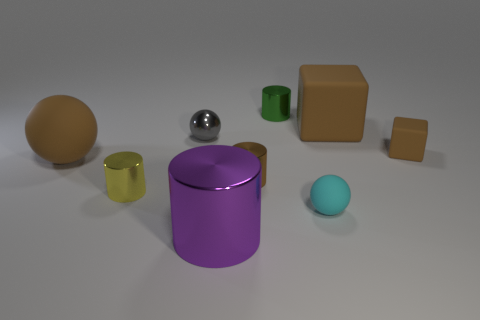Is the big rubber sphere the same color as the large cube?
Your response must be concise. Yes. Are there any tiny rubber objects that have the same color as the large sphere?
Offer a terse response. Yes. What is the shape of the metal thing that is the same color as the large rubber cube?
Offer a very short reply. Cylinder. Is there any other thing of the same color as the large rubber cube?
Ensure brevity in your answer.  Yes. Are there more tiny green matte blocks than yellow cylinders?
Offer a very short reply. No. How many things are both behind the tiny gray metal sphere and right of the cyan matte ball?
Your answer should be compact. 1. What number of cylinders are to the left of the small ball right of the gray shiny object?
Your answer should be compact. 4. There is a metallic ball that is left of the big shiny thing; is it the same size as the brown rubber cube in front of the small gray metallic object?
Your response must be concise. Yes. How many big brown things are there?
Offer a very short reply. 2. What number of yellow objects are the same material as the tiny green cylinder?
Ensure brevity in your answer.  1. 